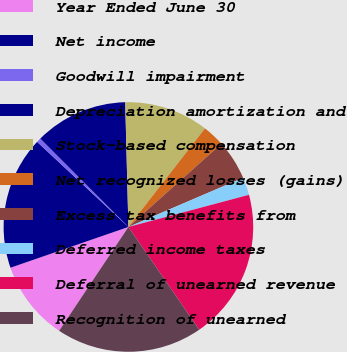Convert chart to OTSL. <chart><loc_0><loc_0><loc_500><loc_500><pie_chart><fcel>Year Ended June 30<fcel>Net income<fcel>Goodwill impairment<fcel>Depreciation amortization and<fcel>Stock-based compensation<fcel>Net recognized losses (gains)<fcel>Excess tax benefits from<fcel>Deferred income taxes<fcel>Deferral of unearned revenue<fcel>Recognition of unearned<nl><fcel>10.34%<fcel>17.24%<fcel>0.58%<fcel>12.07%<fcel>10.92%<fcel>2.87%<fcel>5.17%<fcel>2.3%<fcel>19.54%<fcel>18.97%<nl></chart> 